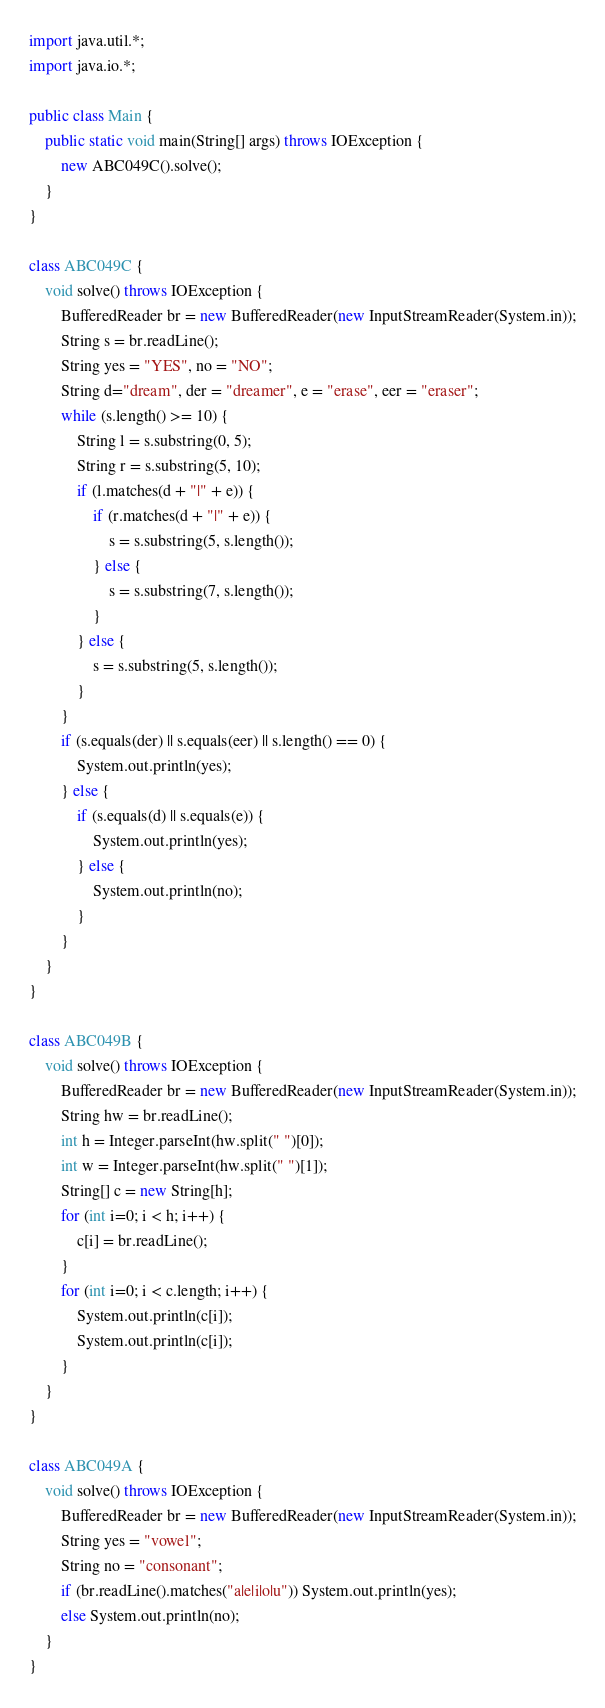Convert code to text. <code><loc_0><loc_0><loc_500><loc_500><_Java_>import java.util.*;
import java.io.*;

public class Main {
	public static void main(String[] args) throws IOException {
		new ABC049C().solve();
	}
}

class ABC049C {
	void solve() throws IOException {
		BufferedReader br = new BufferedReader(new InputStreamReader(System.in));
		String s = br.readLine();
		String yes = "YES", no = "NO";
		String d="dream", der = "dreamer", e = "erase", eer = "eraser";
		while (s.length() >= 10) {
			String l = s.substring(0, 5);
			String r = s.substring(5, 10);
			if (l.matches(d + "|" + e)) {
				if (r.matches(d + "|" + e)) {
					s = s.substring(5, s.length());
				} else {
					s = s.substring(7, s.length());
				}
			} else {
				s = s.substring(5, s.length());
			}
		}
		if (s.equals(der) || s.equals(eer) || s.length() == 0) {
			System.out.println(yes);
		} else {
			if (s.equals(d) || s.equals(e)) {
				System.out.println(yes);
			} else {
				System.out.println(no);
			}
		}
	}
}

class ABC049B {
	void solve() throws IOException {
		BufferedReader br = new BufferedReader(new InputStreamReader(System.in));
		String hw = br.readLine();
		int h = Integer.parseInt(hw.split(" ")[0]);
		int w = Integer.parseInt(hw.split(" ")[1]);
		String[] c = new String[h];
		for (int i=0; i < h; i++) {
			c[i] = br.readLine();
		}
		for (int i=0; i < c.length; i++) {
			System.out.println(c[i]);
			System.out.println(c[i]);
		}
	}
}

class ABC049A {
	void solve() throws IOException {
		BufferedReader br = new BufferedReader(new InputStreamReader(System.in));
		String yes = "vowel";
		String no = "consonant";
		if (br.readLine().matches("a|e|i|o|u")) System.out.println(yes);
		else System.out.println(no);
	}
}
</code> 